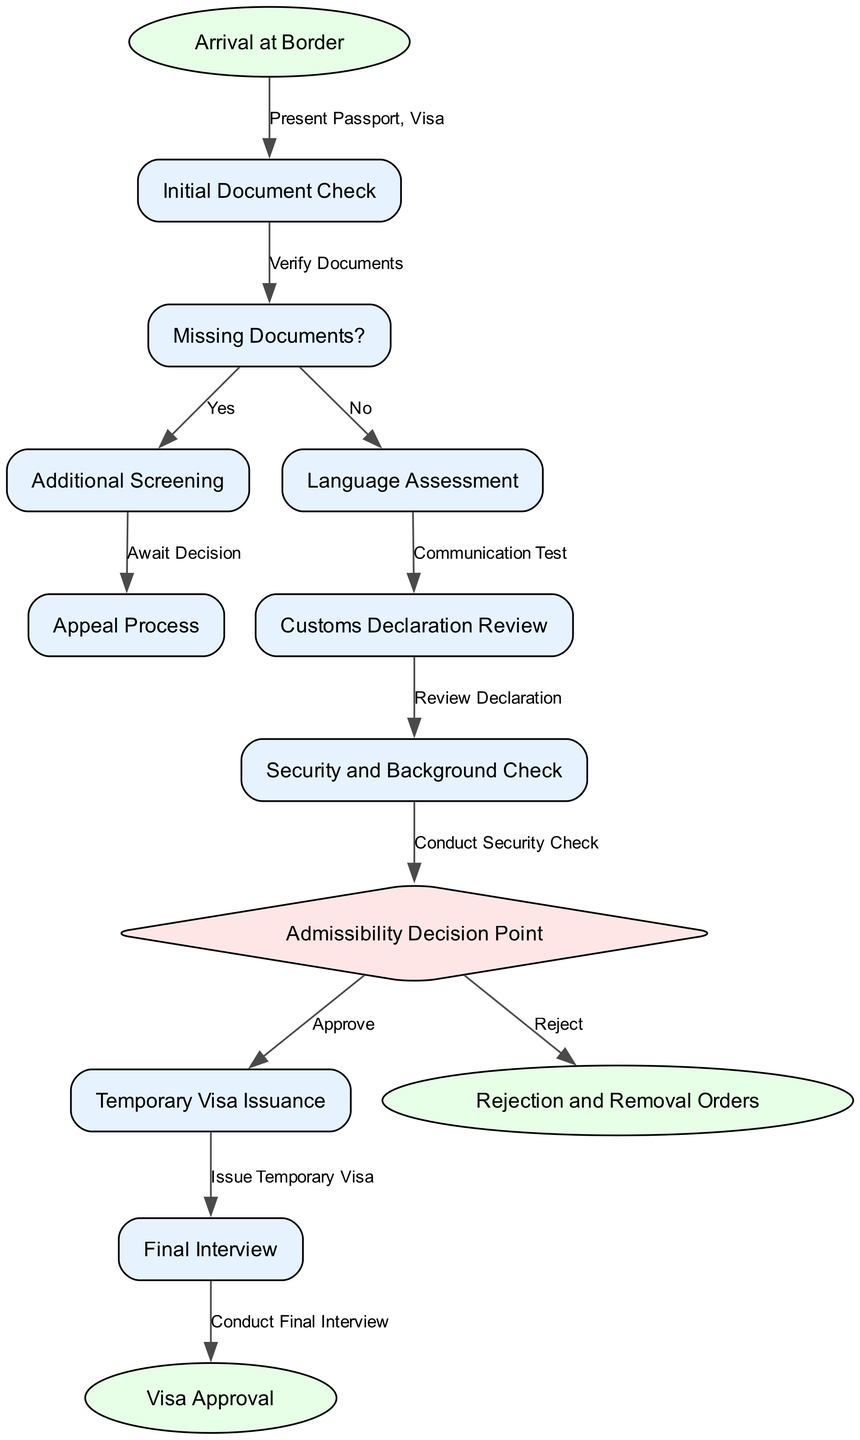What is the first step upon arrival at the border? The first step after arriving at the border is to present the passport and visa. This is indicated in the diagram where the flow starts from "Arrival at Border" to "Initial Document Check."
Answer: Present Passport, Visa How many edges are there leading from the decision point? The decision point has two outgoing edges: one leading to "Temporary Visa Issuance" and the other to "Rejection and Removal Orders." Each edge represents a possible outcome based on the admission decision.
Answer: 2 What follows after the language assessment? After the language assessment, the next step is the customs declaration review, as shown in the diagram with an arrow leading from "Language Assessment" to "Customs Declaration Review."
Answer: Customs Declaration Review What is the outcome of a rejection at the admissibility decision point? The outcome of a rejection at the admissibility decision point is "Rejection and Removal Orders," as indicated in the corresponding edge that connects the two nodes.
Answer: Rejection and Removal Orders If documents are missing, what additional step is taken? If documents are missing, the process moves to "Additional Screening," as outlined in the diagram with a 'Yes' path from the "Missing Documents?" decision point.
Answer: Additional Screening What document is reviewed after customs declaration? Following the customs declaration review, the next step in the process is the security and background check, which is indicated by the edge connecting those two nodes in the flowchart.
Answer: Security and Background Check What happens after the temporary visa is issued? After the temporary visa is issued, the next step is a final interview, as depicted in the diagram with an arrow leading from "Temporary Visa Issuance" to "Final Interview."
Answer: Final Interview What is evaluated at the language assessment step? At the language assessment step, a communication test is conducted to evaluate the individual's language skills, as indicated by the label connecting these two nodes.
Answer: Communication Test How does one move from the initial document check if documents are not missing? If documents are not missing, the process flows from "Initial Document Check" to "Language Assessment," as outlined in the flowchart shown in the diagram.
Answer: Language Assessment 